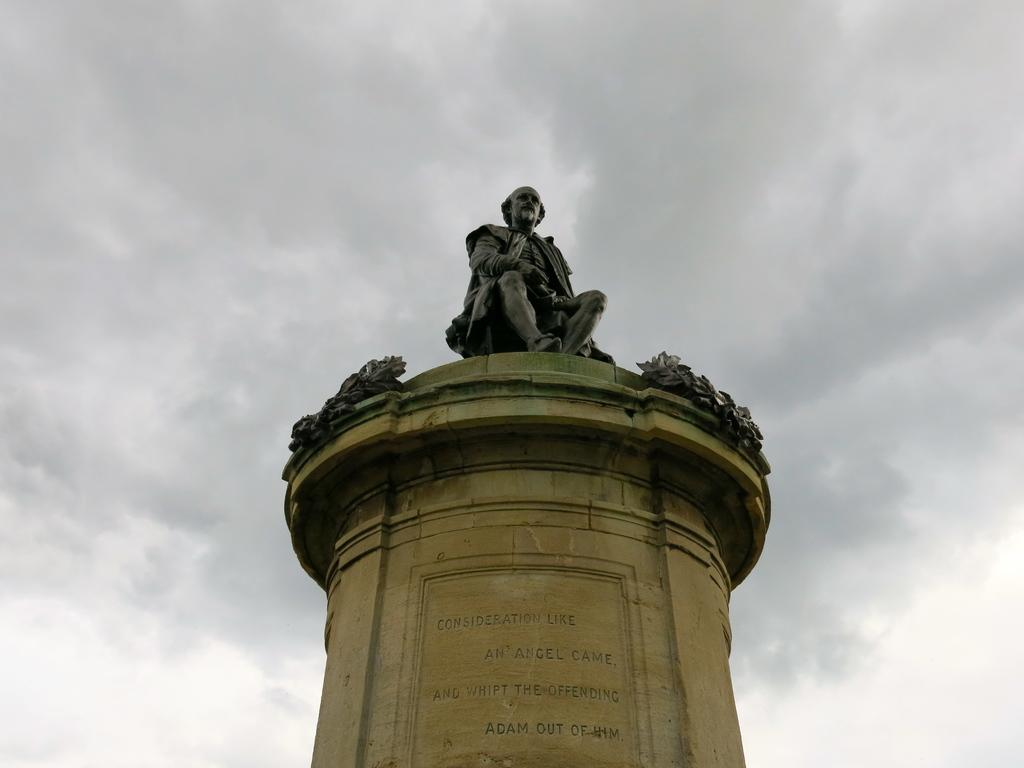What is the main structure in the picture? There is a pillar in the picture. What color is the pillar? The pillar is yellow. Is there anything on top of the pillar? Yes, there is a statue on the pillar. What color is the statue? The statue is black. How many boys are playing during recess in the image? There are no boys or any indication of recess in the image; it features a yellow pillar with a black statue on top. What type of lumber is being used to construct the pillar in the image? The image does not provide information about the construction material of the pillar, but it is not lumber, as the pillar is yellow and the statue is black. 